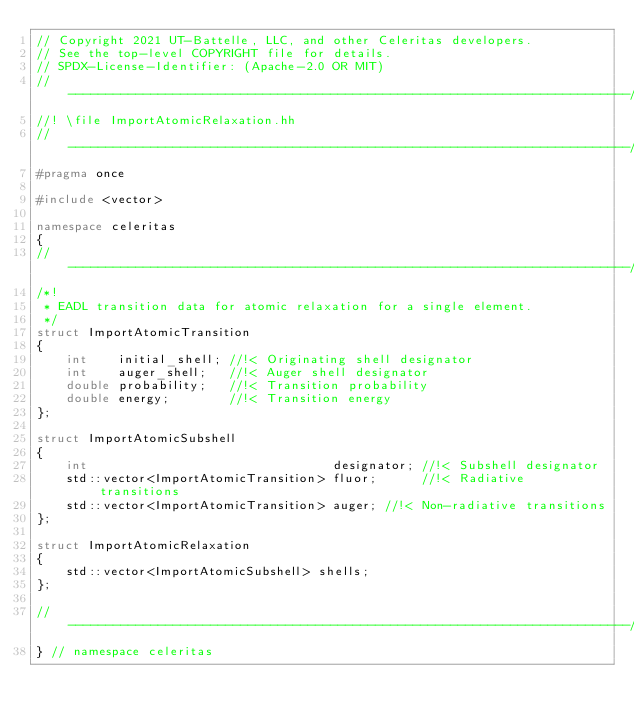Convert code to text. <code><loc_0><loc_0><loc_500><loc_500><_C++_>// Copyright 2021 UT-Battelle, LLC, and other Celeritas developers.
// See the top-level COPYRIGHT file for details.
// SPDX-License-Identifier: (Apache-2.0 OR MIT)
//---------------------------------------------------------------------------//
//! \file ImportAtomicRelaxation.hh
//---------------------------------------------------------------------------//
#pragma once

#include <vector>

namespace celeritas
{
//---------------------------------------------------------------------------//
/*!
 * EADL transition data for atomic relaxation for a single element.
 */
struct ImportAtomicTransition
{
    int    initial_shell; //!< Originating shell designator
    int    auger_shell;   //!< Auger shell designator
    double probability;   //!< Transition probability
    double energy;        //!< Transition energy
};

struct ImportAtomicSubshell
{
    int                                 designator; //!< Subshell designator
    std::vector<ImportAtomicTransition> fluor;      //!< Radiative transitions
    std::vector<ImportAtomicTransition> auger; //!< Non-radiative transitions
};

struct ImportAtomicRelaxation
{
    std::vector<ImportAtomicSubshell> shells;
};

//---------------------------------------------------------------------------//
} // namespace celeritas
</code> 